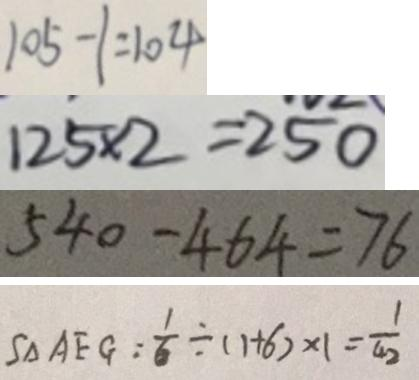Convert formula to latex. <formula><loc_0><loc_0><loc_500><loc_500>1 0 5 - 1 = 1 0 4 
 1 2 5 \times 2 = 2 5 0 
 5 4 0 - 4 6 4 = 7 6 
 S _ { \Delta } A E G = \frac { 1 } { 6 } \div ( 1 + 6 ) \times 1 = \frac { 1 } { 4 2 }</formula> 